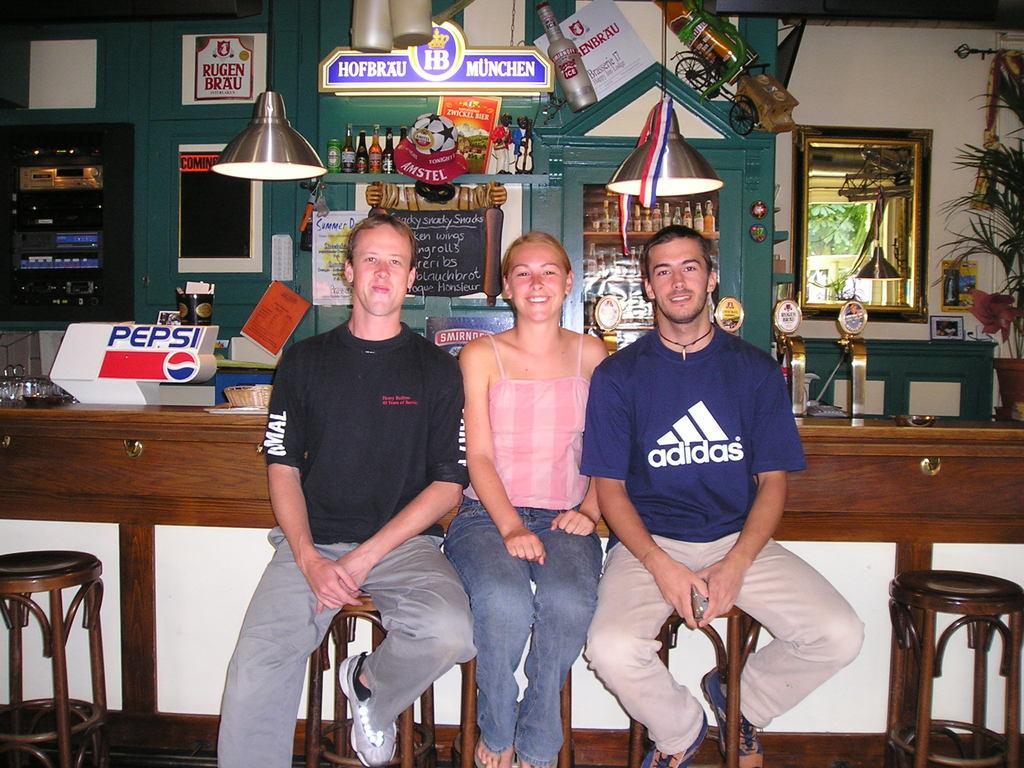Can you describe this image briefly? in the foreground of the picture there are stools and persons. In the middle of the picture there are bottles, desk, boards, light, glasses, houseplant and various objects. Towards right there is a window, outside the window we can see tree. 